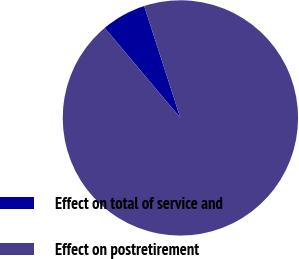<chart> <loc_0><loc_0><loc_500><loc_500><pie_chart><fcel>Effect on total of service and<fcel>Effect on postretirement<nl><fcel>6.14%<fcel>93.86%<nl></chart> 